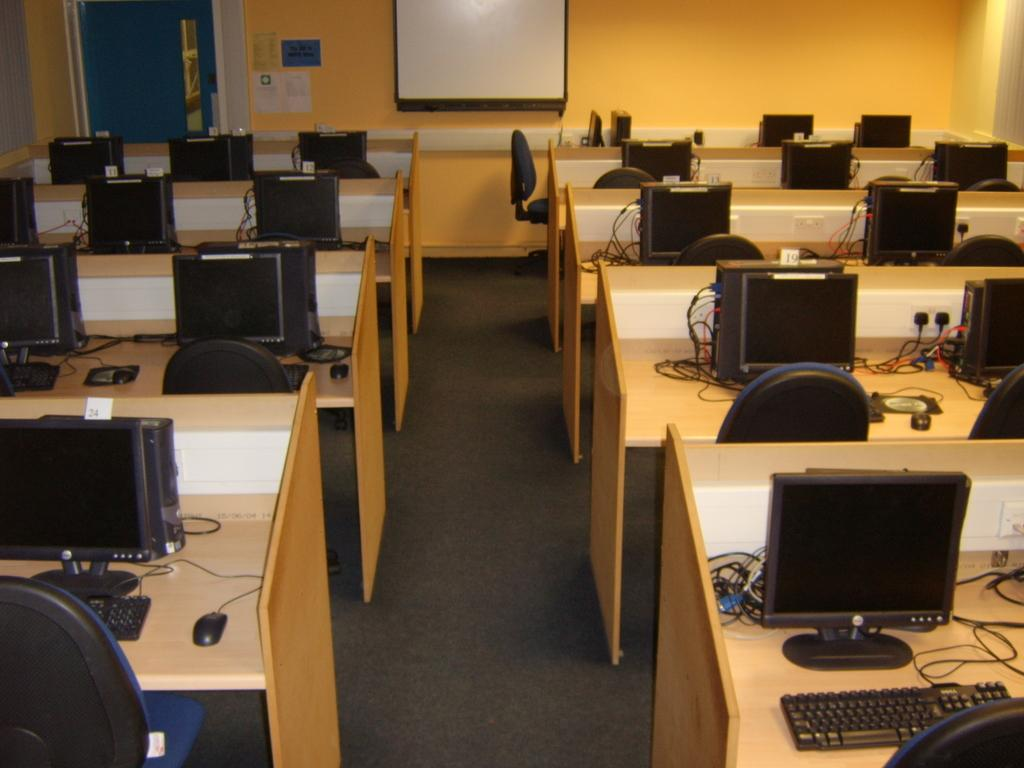What type of electronic devices can be seen in the image? There are monitors and keyboards in the image. What are the monitors and keyboards connected to? Cables are visible in the image, which connect the monitors and keyboards. What type of input devices are present in the image? There are mouses in the image. What type of furniture is in the image? There are chairs in the image. What is the noticeable board used for in the image? There is a notice board in the image. What type of joke can be seen written on the notice board in the image? There is no joke present on the notice board in the image. What is the mass of the monitors in the image? The mass of the monitors cannot be determined from the image alone. 